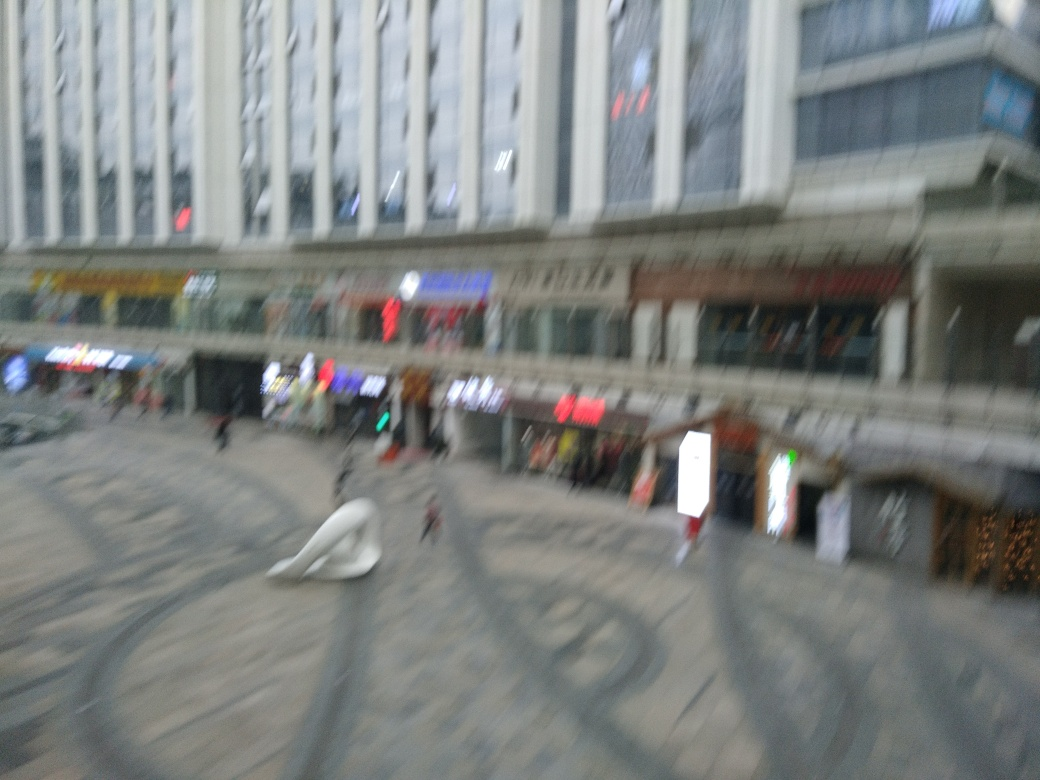Are there any quality issues with this image? Yes, the image appears to be quite blurred, which could be due to camera motion during the shot or a focus issue, resulting in a loss of detail that affects the overall clarity. 